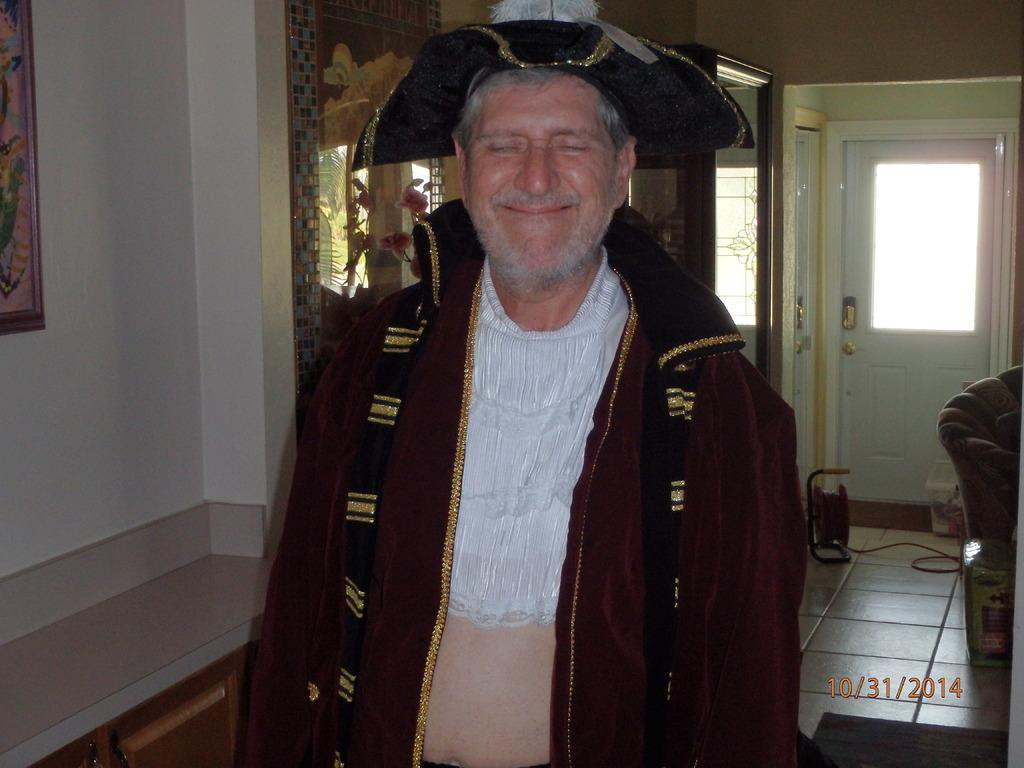What is the person in the room doing? The fact does not specify what the person is doing, so we cannot determine their activity from the given information. What can be seen on the left side of the wall in the room? There is a photo frame on the left side of the wall. How can someone enter or exit the room? There is a door in the room for entering or exiting. What type of furniture is in the room? There is a couch in the room. What else is present on the floor in the room? There are other objects on the floor, but their specific nature is not mentioned in the facts. What type of toys are scattered on the floor in the image? There is no mention of toys in the given facts, so we cannot determine if any toys are present in the image. What color is the jelly on the couch in the image? There is no mention of jelly in the given facts, so we cannot determine if any jelly is present in the image. 